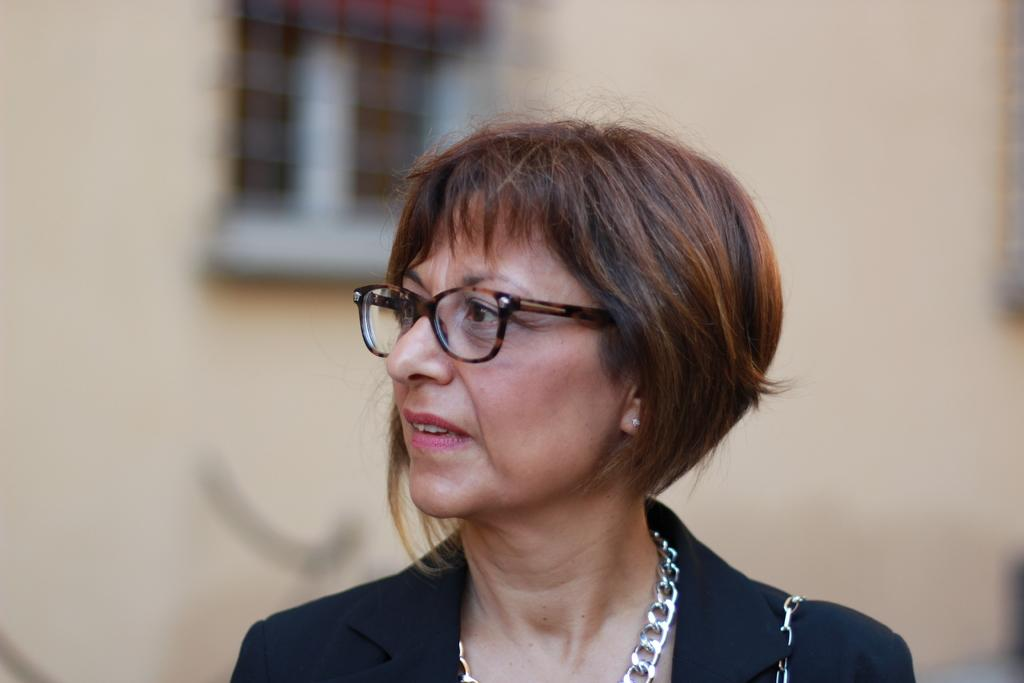Who is the main subject in the image? There is a woman in the image. What accessory is the woman wearing? The woman is wearing glasses. How would you describe the background of the image? The background of the image is blurred. Can you describe the main feature of the background? There is a plain wall in the background of the image. Are there any other objects visible in the background? Yes, there is an unspecified object in the background of the image. What year is displayed on the calculator in the image? There is no calculator present in the image, so the year cannot be determined. What type of drug is the woman holding in the image? There is no drug present in the image; the woman is wearing glasses and standing in front of a blurred background. 